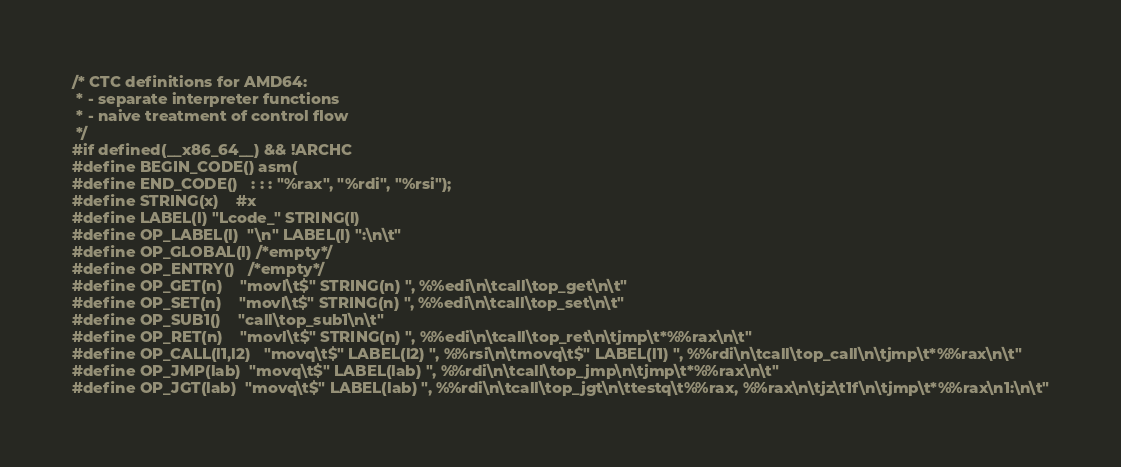<code> <loc_0><loc_0><loc_500><loc_500><_C_>/* CTC definitions for AMD64:
 * - separate interpreter functions
 * - naive treatment of control flow
 */
#if defined(__x86_64__) && !ARCHC
#define BEGIN_CODE()	asm(
#define END_CODE()	: : : "%rax", "%rdi", "%rsi");
#define STRING(x)	#x
#define LABEL(l)	"Lcode_" STRING(l)
#define OP_LABEL(l)	"\n" LABEL(l) ":\n\t"
#define OP_GLOBAL(l)	/*empty*/
#define OP_ENTRY()	/*empty*/ 
#define OP_GET(n)	"movl\t$" STRING(n) ", %%edi\n\tcall\top_get\n\t"
#define OP_SET(n)	"movl\t$" STRING(n) ", %%edi\n\tcall\top_set\n\t"
#define OP_SUB1()	"call\top_sub1\n\t"
#define OP_RET(n)	"movl\t$" STRING(n) ", %%edi\n\tcall\top_ret\n\tjmp\t*%%rax\n\t"
#define OP_CALL(l1,l2)	"movq\t$" LABEL(l2) ", %%rsi\n\tmovq\t$" LABEL(l1) ", %%rdi\n\tcall\top_call\n\tjmp\t*%%rax\n\t"
#define OP_JMP(lab)	"movq\t$" LABEL(lab) ", %%rdi\n\tcall\top_jmp\n\tjmp\t*%%rax\n\t"
#define OP_JGT(lab)	"movq\t$" LABEL(lab) ", %%rdi\n\tcall\top_jgt\n\ttestq\t%%rax, %%rax\n\tjz\t1f\n\tjmp\t*%%rax\n1:\n\t"</code> 